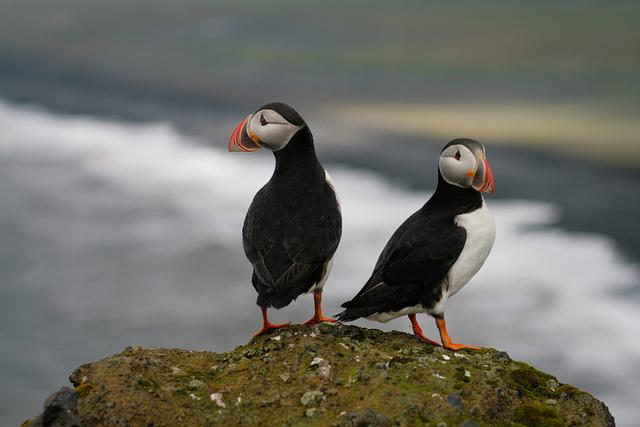Can these birds be found on the coast?
Keep it brief. Yes. Are his eyes close?
Give a very brief answer. No. Are these birds facing each other?
Concise answer only. No. Is this a desert?
Answer briefly. No. 